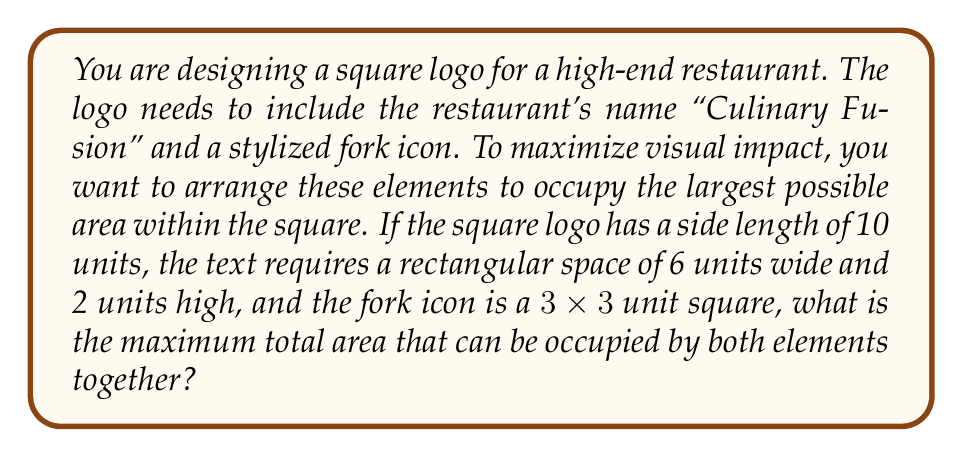Solve this math problem. To solve this problem, we need to consider the most efficient arrangement of the two elements within the square logo. Let's approach this step-by-step:

1) We have a square logo with side length 10 units, so the total area is 100 square units.

2) The text element is a rectangle of 6x2 units, with an area of 12 square units.

3) The fork icon is a 3x3 square, with an area of 9 square units.

4) To maximize the occupied area, we need to place these elements without overlap and with minimal wasted space.

5) The most efficient arrangement would be to place the text rectangle and the fork icon side by side horizontally:

   [asy]
   unitsize(0.5cm);
   draw(box((0,0),(10,10)));
   fill(box((0.5,3.5),(6.5,5.5)), gray);
   fill(box((7,3.5),(10,6.5)), gray);
   label("Text", (3.5,4.5));
   label("Fork", (8.5,5));
   [/asy]

6) In this arrangement, the total width occupied is 6 + 3 = 9 units, which fits within the 10-unit width of the logo.

7) The height occupied is the maximum of the two elements' heights, which is 3 units (the height of the fork icon).

8) Therefore, the total area occupied by both elements is:

   $$A = 6 \times 2 + 3 \times 3 = 12 + 9 = 21$$

   square units.

This arrangement maximizes the occupied area while fitting both elements within the square logo.
Answer: The maximum total area that can be occupied by both elements together is 21 square units. 